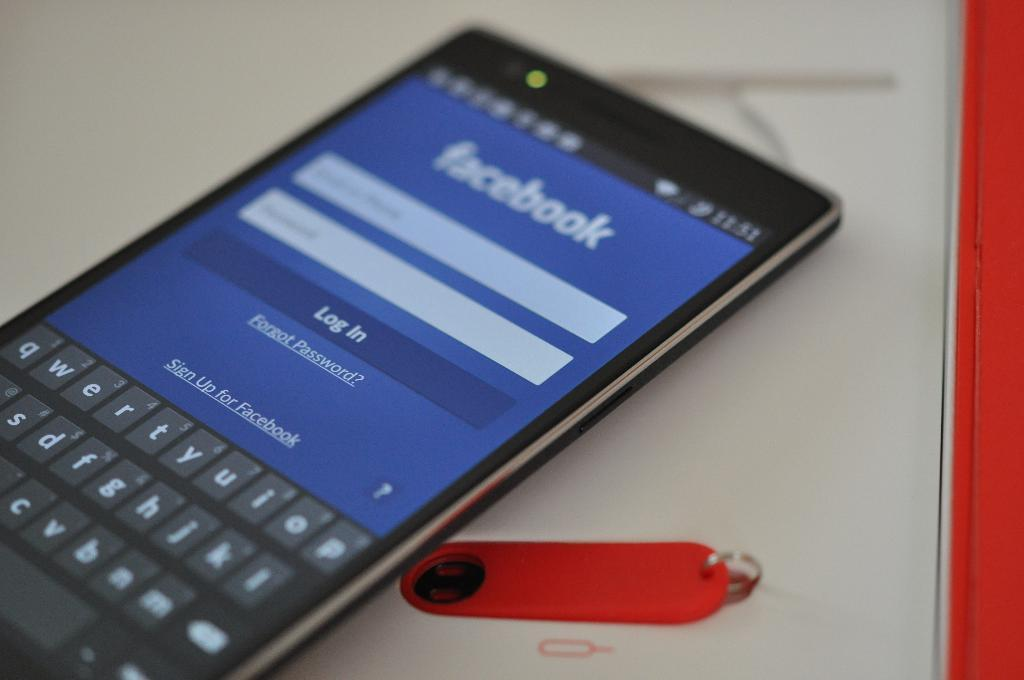<image>
Share a concise interpretation of the image provided. a cell phone with a facebook screen open on the home screen 